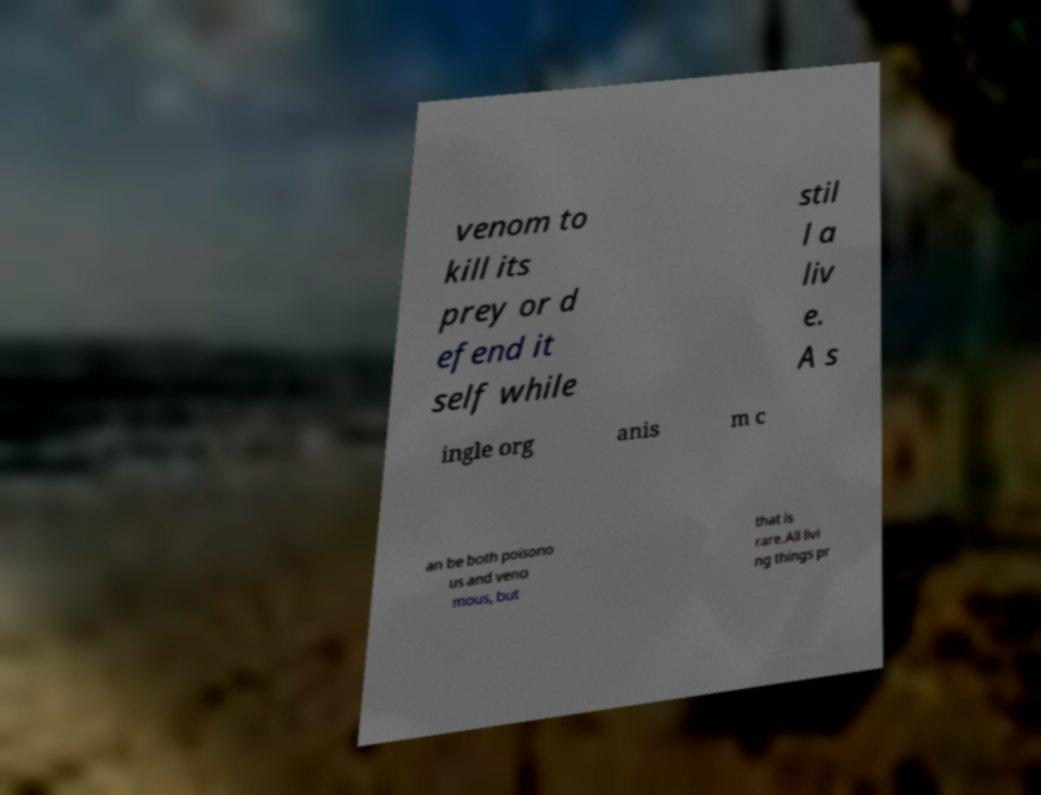Can you accurately transcribe the text from the provided image for me? venom to kill its prey or d efend it self while stil l a liv e. A s ingle org anis m c an be both poisono us and veno mous, but that is rare.All livi ng things pr 